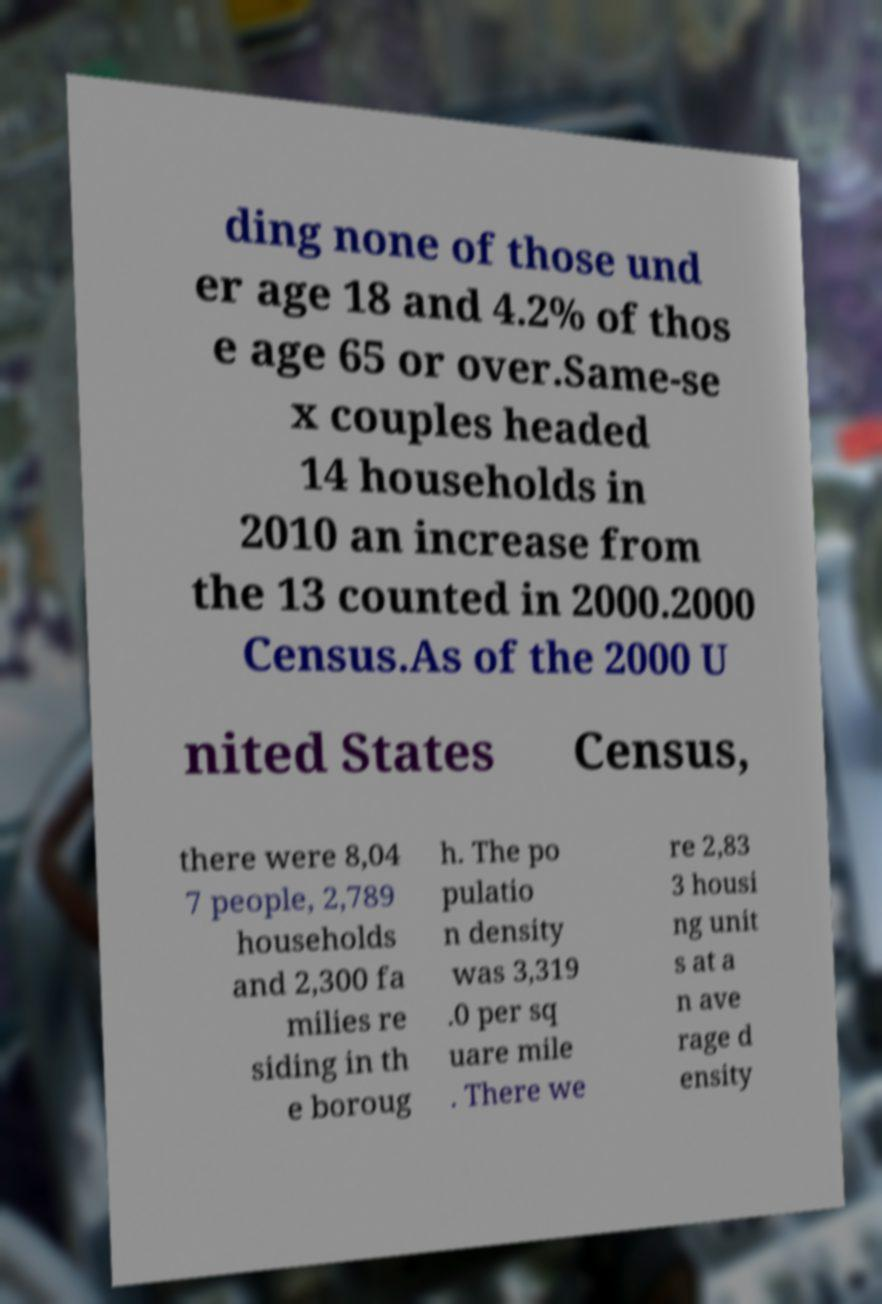Could you assist in decoding the text presented in this image and type it out clearly? ding none of those und er age 18 and 4.2% of thos e age 65 or over.Same-se x couples headed 14 households in 2010 an increase from the 13 counted in 2000.2000 Census.As of the 2000 U nited States Census, there were 8,04 7 people, 2,789 households and 2,300 fa milies re siding in th e boroug h. The po pulatio n density was 3,319 .0 per sq uare mile . There we re 2,83 3 housi ng unit s at a n ave rage d ensity 